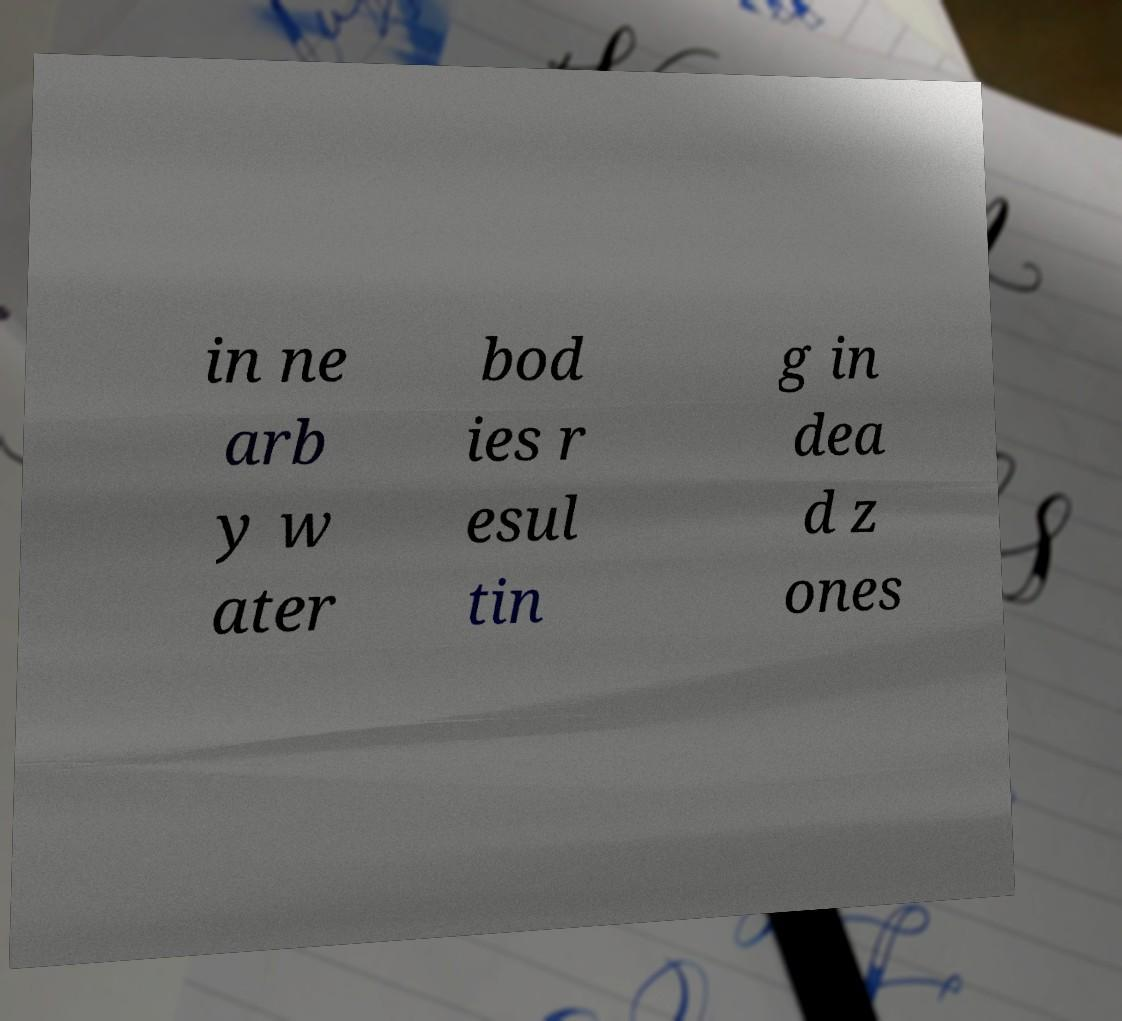I need the written content from this picture converted into text. Can you do that? in ne arb y w ater bod ies r esul tin g in dea d z ones 